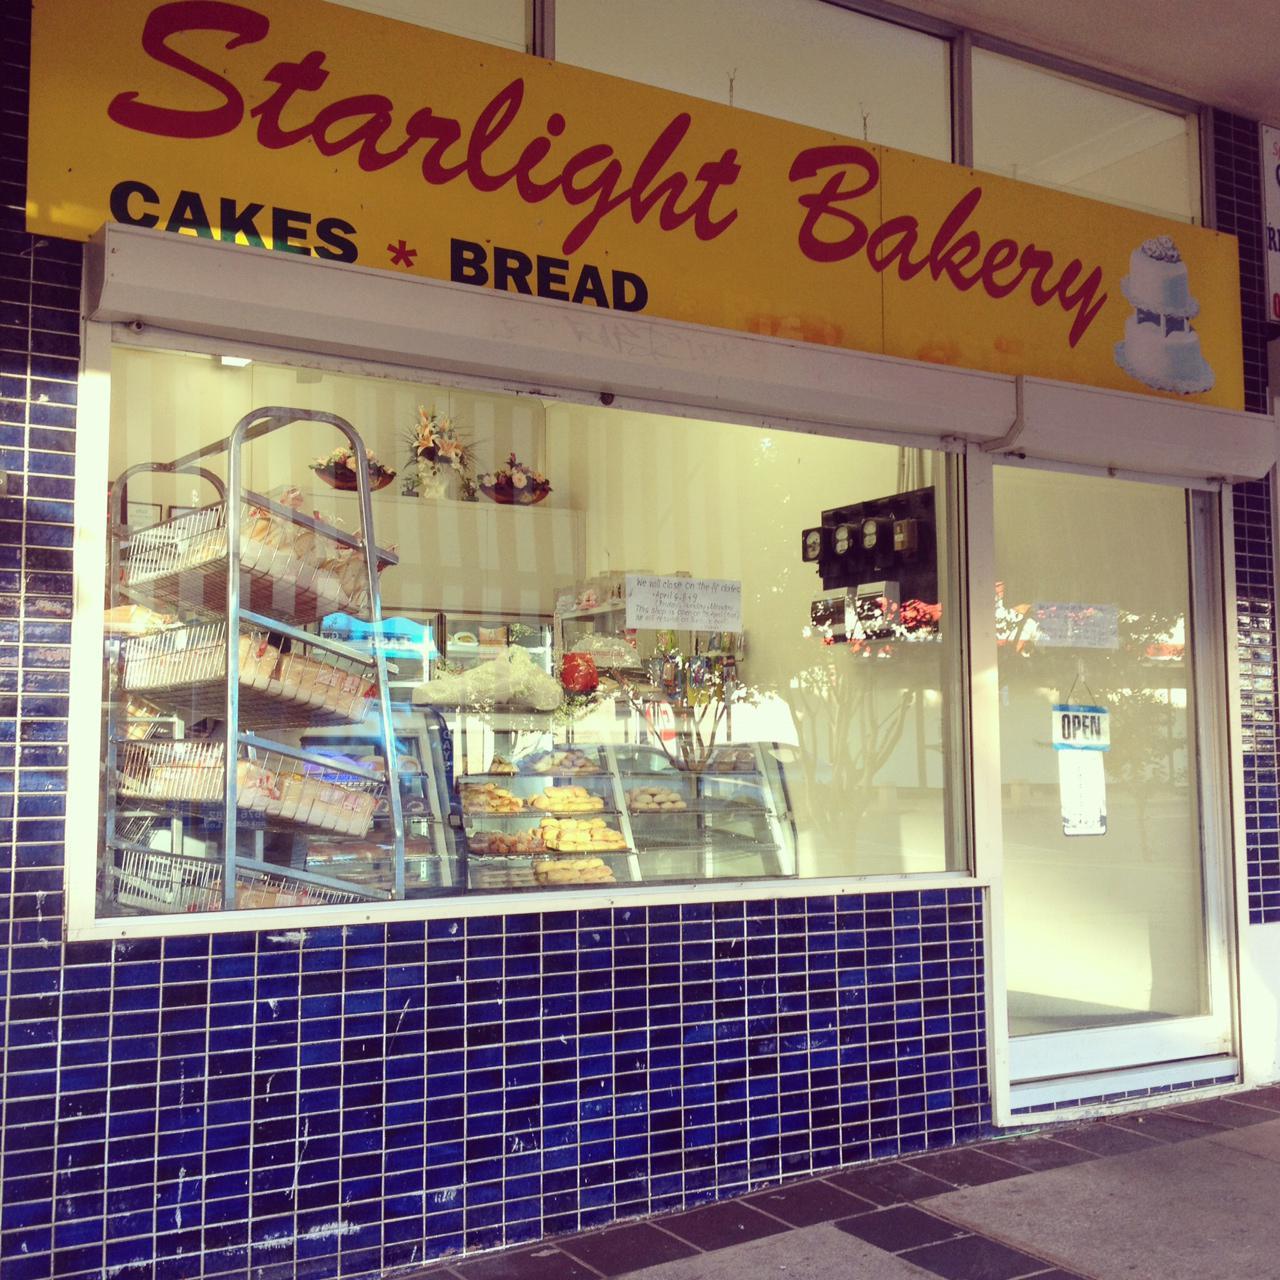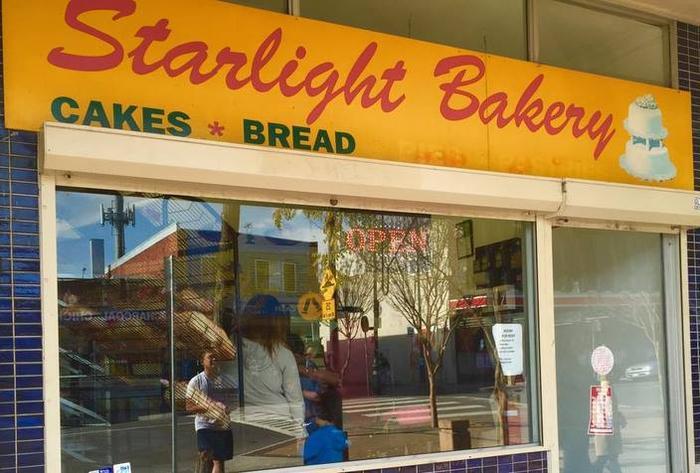The first image is the image on the left, the second image is the image on the right. For the images displayed, is the sentence "Both images show bakeries with the same name." factually correct? Answer yes or no. Yes. The first image is the image on the left, the second image is the image on the right. Assess this claim about the two images: "People are standing in front of a restaurant.". Correct or not? Answer yes or no. No. 